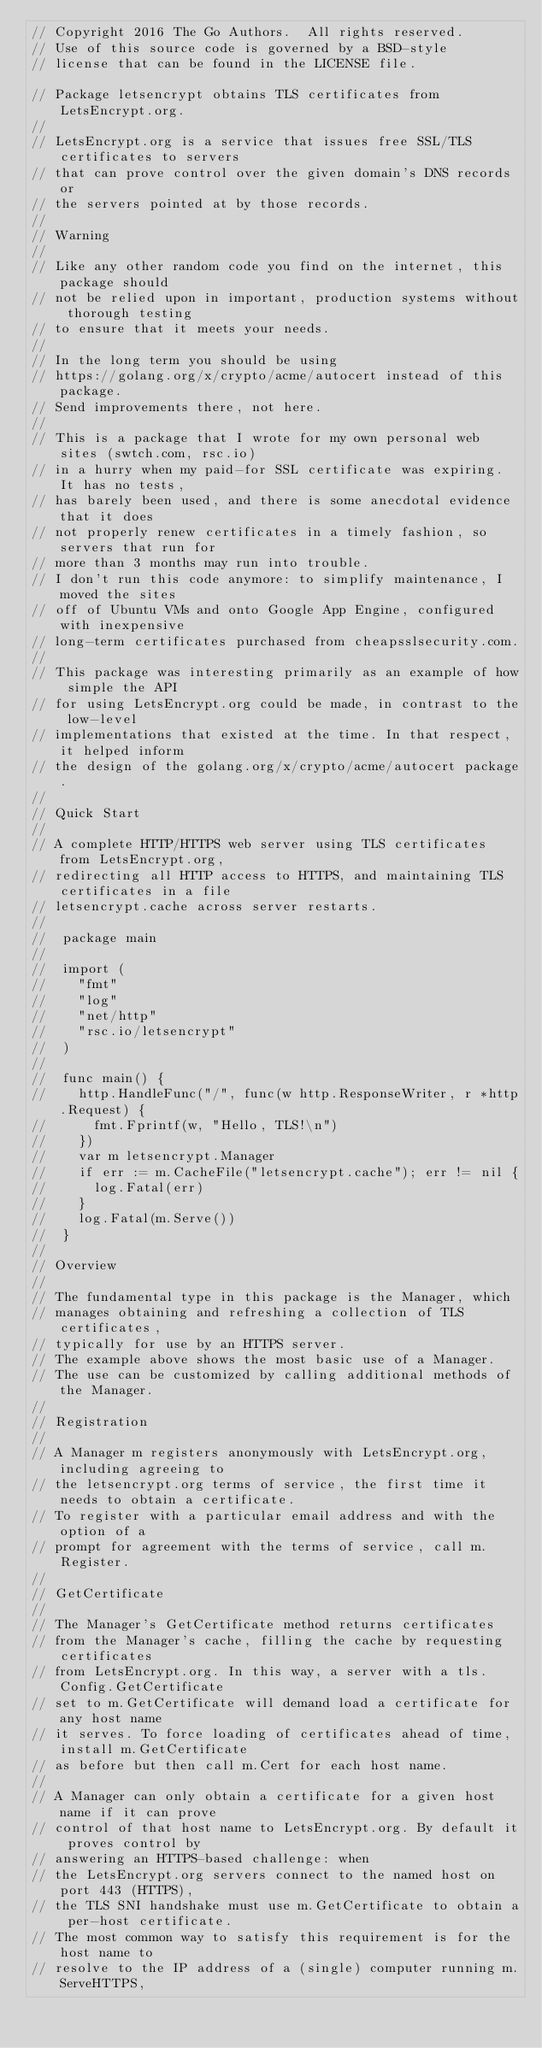<code> <loc_0><loc_0><loc_500><loc_500><_Go_>// Copyright 2016 The Go Authors.  All rights reserved.
// Use of this source code is governed by a BSD-style
// license that can be found in the LICENSE file.

// Package letsencrypt obtains TLS certificates from LetsEncrypt.org.
//
// LetsEncrypt.org is a service that issues free SSL/TLS certificates to servers
// that can prove control over the given domain's DNS records or
// the servers pointed at by those records.
//
// Warning
//
// Like any other random code you find on the internet, this package should
// not be relied upon in important, production systems without thorough testing
// to ensure that it meets your needs.
//
// In the long term you should be using
// https://golang.org/x/crypto/acme/autocert instead of this package.
// Send improvements there, not here.
//
// This is a package that I wrote for my own personal web sites (swtch.com, rsc.io)
// in a hurry when my paid-for SSL certificate was expiring. It has no tests,
// has barely been used, and there is some anecdotal evidence that it does
// not properly renew certificates in a timely fashion, so servers that run for
// more than 3 months may run into trouble.
// I don't run this code anymore: to simplify maintenance, I moved the sites
// off of Ubuntu VMs and onto Google App Engine, configured with inexpensive
// long-term certificates purchased from cheapsslsecurity.com.
//
// This package was interesting primarily as an example of how simple the API
// for using LetsEncrypt.org could be made, in contrast to the low-level
// implementations that existed at the time. In that respect, it helped inform
// the design of the golang.org/x/crypto/acme/autocert package.
//
// Quick Start
//
// A complete HTTP/HTTPS web server using TLS certificates from LetsEncrypt.org,
// redirecting all HTTP access to HTTPS, and maintaining TLS certificates in a file
// letsencrypt.cache across server restarts.
//
//	package main
//
//	import (
//		"fmt"
//		"log"
//		"net/http"
//		"rsc.io/letsencrypt"
//	)
//
//	func main() {
//		http.HandleFunc("/", func(w http.ResponseWriter, r *http.Request) {
//			fmt.Fprintf(w, "Hello, TLS!\n")
//		})
//		var m letsencrypt.Manager
//		if err := m.CacheFile("letsencrypt.cache"); err != nil {
//			log.Fatal(err)
//		}
//		log.Fatal(m.Serve())
//	}
//
// Overview
//
// The fundamental type in this package is the Manager, which
// manages obtaining and refreshing a collection of TLS certificates,
// typically for use by an HTTPS server.
// The example above shows the most basic use of a Manager.
// The use can be customized by calling additional methods of the Manager.
//
// Registration
//
// A Manager m registers anonymously with LetsEncrypt.org, including agreeing to
// the letsencrypt.org terms of service, the first time it needs to obtain a certificate.
// To register with a particular email address and with the option of a
// prompt for agreement with the terms of service, call m.Register.
//
// GetCertificate
//
// The Manager's GetCertificate method returns certificates
// from the Manager's cache, filling the cache by requesting certificates
// from LetsEncrypt.org. In this way, a server with a tls.Config.GetCertificate
// set to m.GetCertificate will demand load a certificate for any host name
// it serves. To force loading of certificates ahead of time, install m.GetCertificate
// as before but then call m.Cert for each host name.
//
// A Manager can only obtain a certificate for a given host name if it can prove
// control of that host name to LetsEncrypt.org. By default it proves control by
// answering an HTTPS-based challenge: when
// the LetsEncrypt.org servers connect to the named host on port 443 (HTTPS),
// the TLS SNI handshake must use m.GetCertificate to obtain a per-host certificate.
// The most common way to satisfy this requirement is for the host name to
// resolve to the IP address of a (single) computer running m.ServeHTTPS,</code> 